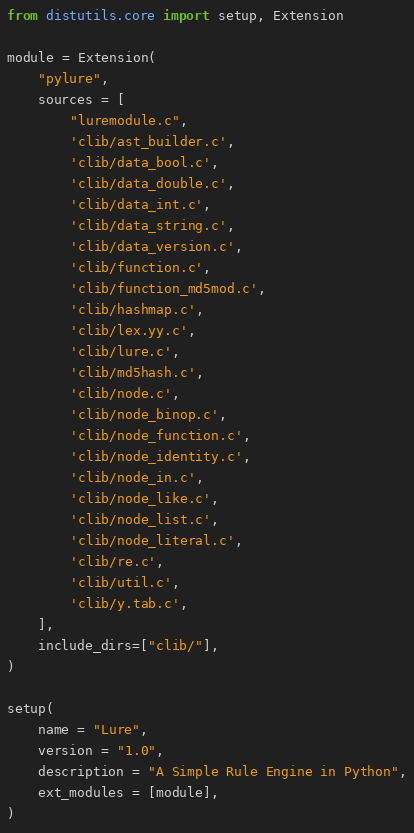<code> <loc_0><loc_0><loc_500><loc_500><_Python_>from distutils.core import setup, Extension

module = Extension(
    "pylure", 
    sources = [
        "luremodule.c",
        'clib/ast_builder.c',
        'clib/data_bool.c',
        'clib/data_double.c',
        'clib/data_int.c',
        'clib/data_string.c',
        'clib/data_version.c',
        'clib/function.c',
        'clib/function_md5mod.c',
        'clib/hashmap.c',
        'clib/lex.yy.c',
        'clib/lure.c',
        'clib/md5hash.c',
        'clib/node.c',
        'clib/node_binop.c',
        'clib/node_function.c',
        'clib/node_identity.c',
        'clib/node_in.c',
        'clib/node_like.c',
        'clib/node_list.c',
        'clib/node_literal.c',
        'clib/re.c',
        'clib/util.c',
        'clib/y.tab.c',
    ],
    include_dirs=["clib/"],
)

setup(
    name = "Lure",
    version = "1.0",
    description = "A Simple Rule Engine in Python",
    ext_modules = [module],
)</code> 